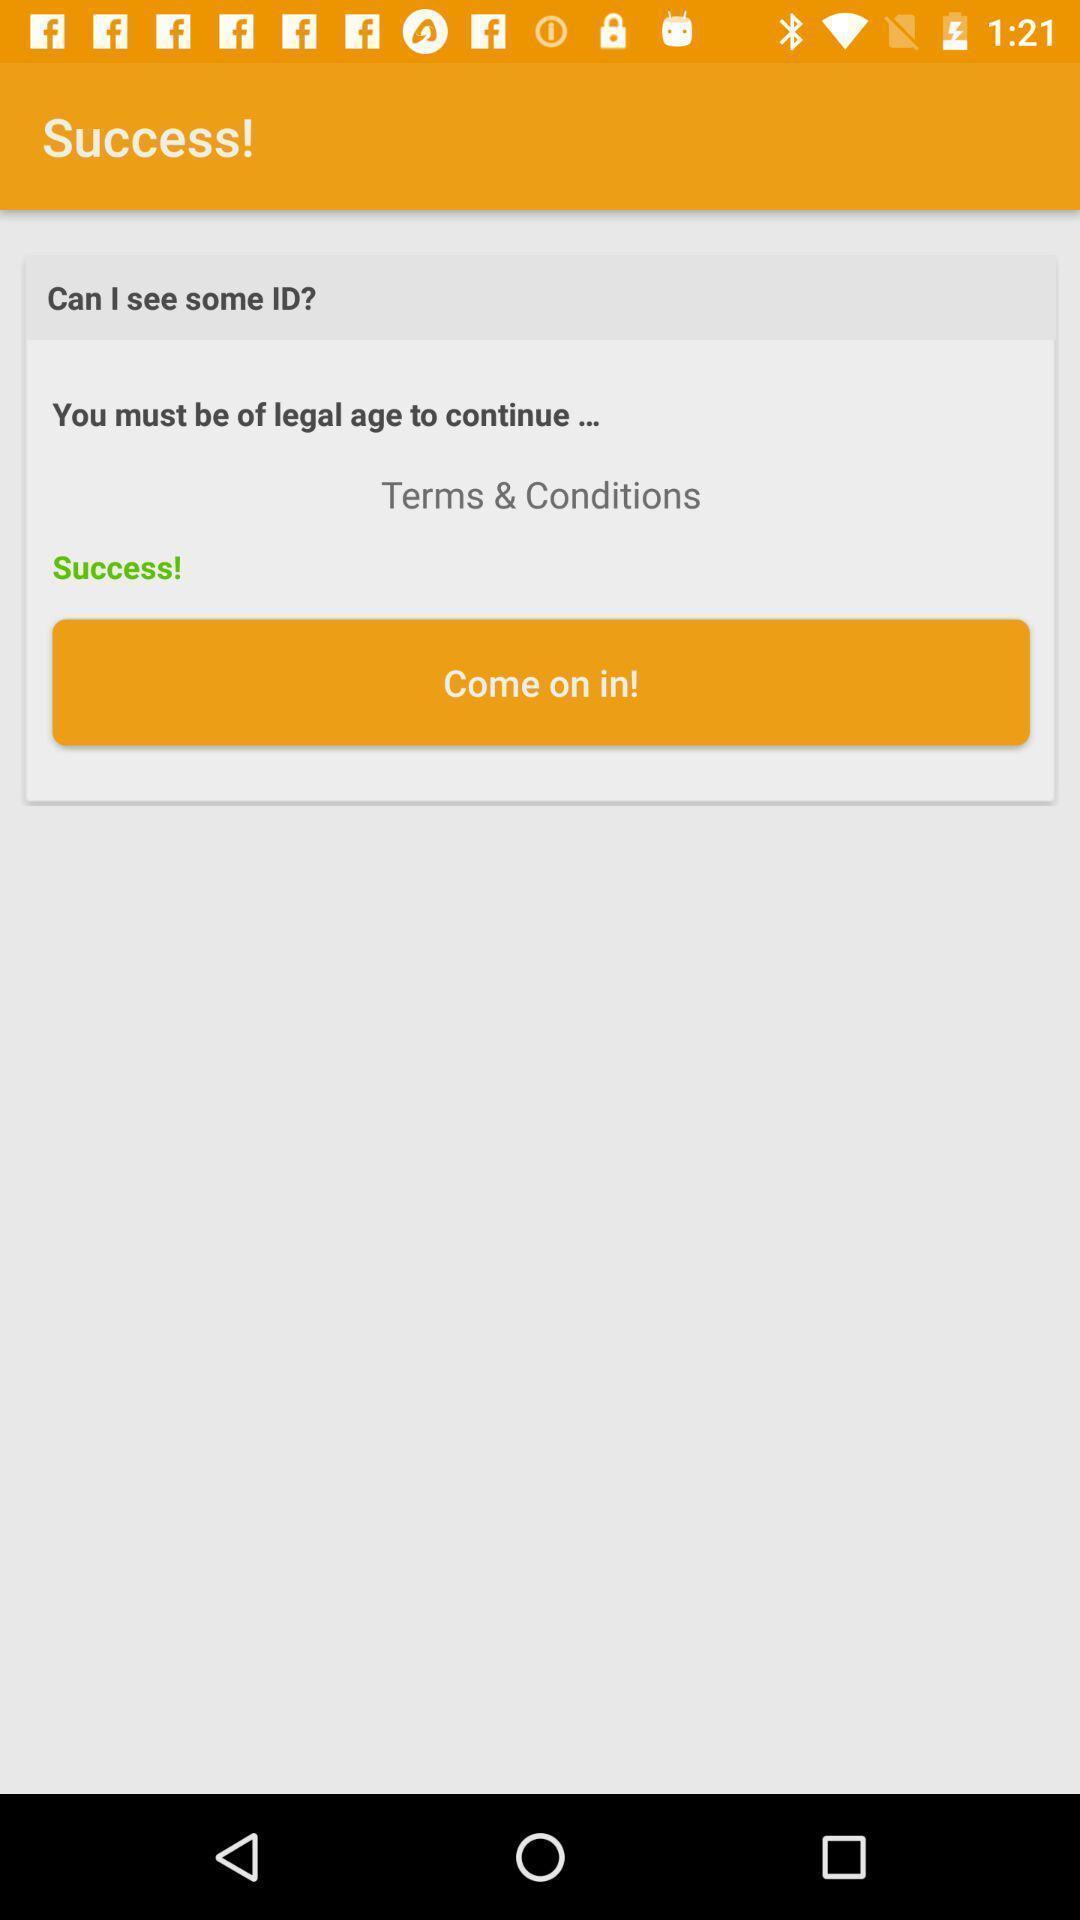Give me a summary of this screen capture. Success page showing terms conditions. 